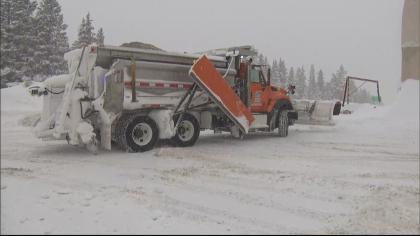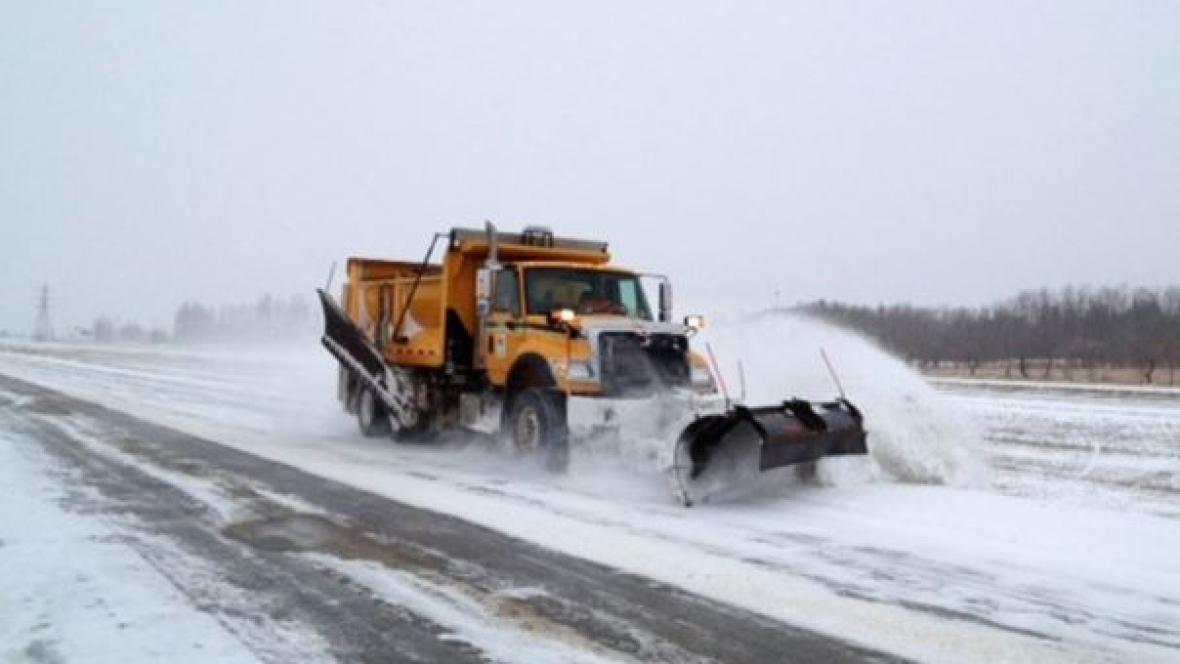The first image is the image on the left, the second image is the image on the right. Assess this claim about the two images: "An image shows a truck with wheels instead of tank tracks heading rightward pushing snow, and the truck bed is bright yellow.". Correct or not? Answer yes or no. Yes. The first image is the image on the left, the second image is the image on the right. Considering the images on both sides, is "The yellow truck is pushing the snow in the image on the left." valid? Answer yes or no. No. 